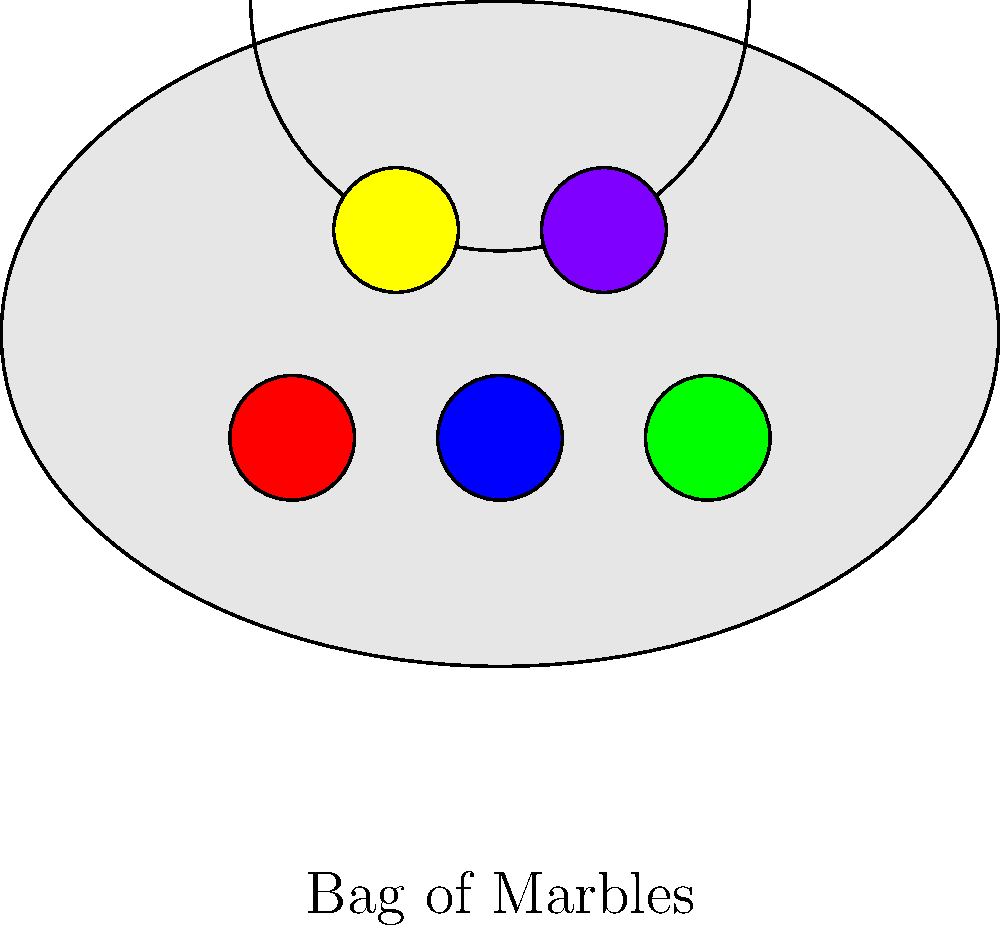You have a bag containing 5 marbles of different colors: red, blue, green, yellow, and purple. Without looking, you reach into the bag and grab a marble. What is the probability of drawing a blue marble? To answer this question, create a physical model using a small bag and colored objects to represent the marbles. Draw the marbles one at a time, recording the results, and repeat this process multiple times to estimate the probability. To solve this problem using a hands-on approach, follow these steps:

1. Gather materials: a small bag and 5 objects of different colors (red, blue, green, yellow, and purple) to represent the marbles.

2. Place all 5 "marbles" in the bag.

3. Without looking, reach into the bag and draw one marble. Record its color.

4. Replace the marble in the bag.

5. Repeat steps 3-4 many times (e.g., 50 or 100 draws) to get a good sample size.

6. Count the number of times you drew a blue marble.

7. Calculate the experimental probability using the formula:

   $$P(\text{blue}) = \frac{\text{Number of times blue was drawn}}{\text{Total number of draws}}$$

8. Compare your experimental result to the theoretical probability:

   $$P(\text{blue}) = \frac{\text{Number of blue marbles}}{\text{Total number of marbles}} = \frac{1}{5} = 0.2$$

9. The more trials you perform, the closer your experimental probability should get to the theoretical probability of $\frac{1}{5}$ or 0.2.

This hands-on approach helps kinesthetic learners understand the concept of probability through physical manipulation and repeated trials.
Answer: $\frac{1}{5}$ or 0.2 